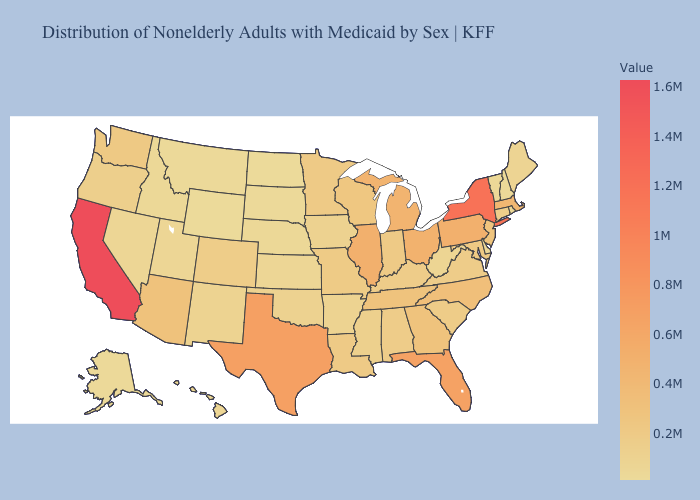Does Arizona have a lower value than Alaska?
Be succinct. No. Among the states that border Kansas , does Nebraska have the highest value?
Quick response, please. No. Does Georgia have the lowest value in the USA?
Give a very brief answer. No. Does Oklahoma have a lower value than New York?
Short answer required. Yes. Among the states that border Colorado , which have the highest value?
Be succinct. Arizona. Which states hav the highest value in the Northeast?
Give a very brief answer. New York. Does Montana have a lower value than Minnesota?
Answer briefly. Yes. Which states hav the highest value in the West?
Keep it brief. California. Among the states that border Arkansas , does Texas have the highest value?
Keep it brief. Yes. 